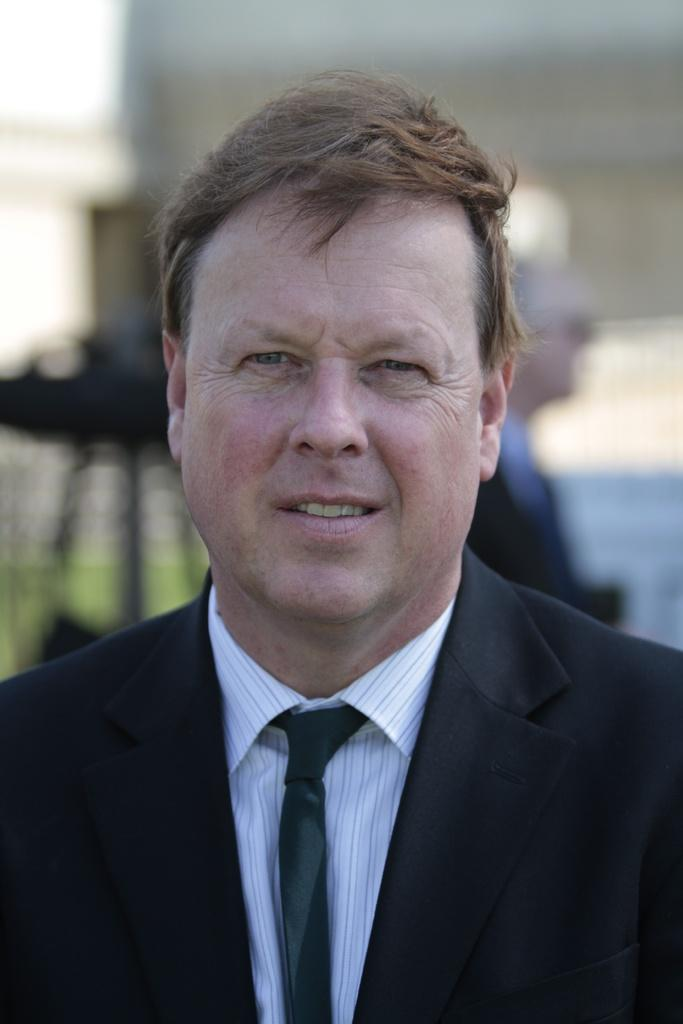What is the main subject of the image? There is a person in the image. What is the person wearing on their upper body? The person is wearing a black blazer, a white shirt, and a black color tie. Can you describe the background of the image? There is another person in the background of the image, and the wall is white. Are there any curves visible in the person's tie in the image? There is no mention of curves in the person's tie in the image. The tie is described as being black in color. --- Facts: 1. There is a car in the image. 2. The car is red. 3. The car has four wheels. 4. There are people in the car. 5. The car is parked on the street. Absurd Topics: parrot, sand, volcano Conversation: What is the main subject of the image? There is a car in the image. What color is the car? The car is red. How many wheels does the car have? The car has four wheels. Are there any passengers in the car? Yes, there are people in the car. Where is the car located in the image? The car is parked on the street. Reasoning: Let's think step by step in order to produce the conversation. We start by identifying the main subject of the image, which is the car. Then, we describe the car's color and the number of wheels it has. Next, we mention the presence of passengers in the car. Finally, we describe the car's location, which is parked on the street. Each question is designed to elicit a specific detail about the image that is known from the provided facts. Absurd Question/Answer: Can you see a parrot sitting on the car's roof in the image? There is no mention of a parrot in the image. The image only features a red car with four wheels and people inside. --- Facts: 1. There is a dog in the image. 2. The dog is brown. 3. The dog is sitting on a rug. 4. There is a toy in the image. 5. The toy is a ball. Absurd Topics: fish, mountain, bicycle Conversation: What is the main subject of the image? There is a dog in the image. What color is the dog? The dog is brown. What is the dog sitting on? The dog is sitting on a rug. What other object is present in the image? There is a toy in the image. What type of toy is it? The toy is a ball. Reasoning: Let's think step by step in order to produce the conversation. We start by identifying the main 